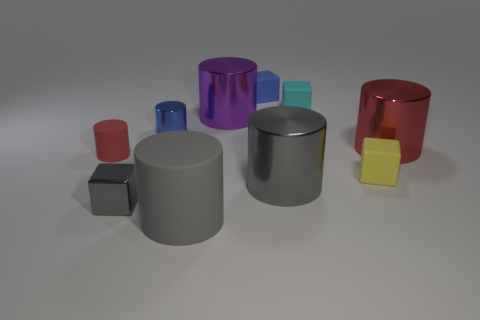Is the number of big gray objects behind the tiny blue metallic cylinder the same as the number of gray matte cylinders behind the yellow block?
Offer a terse response. Yes. There is a tiny metallic thing behind the red cylinder on the left side of the large purple metal thing; are there any metal cubes that are to the left of it?
Provide a succinct answer. Yes. Do the gray block and the blue metallic cylinder have the same size?
Your response must be concise. Yes. There is a cylinder left of the tiny shiny thing in front of the red cylinder left of the big red metal cylinder; what is its color?
Your answer should be compact. Red. How many big rubber objects have the same color as the shiny cube?
Offer a very short reply. 1. What number of tiny objects are either red metallic cylinders or brown matte spheres?
Offer a very short reply. 0. Is there a small blue rubber thing that has the same shape as the yellow matte thing?
Ensure brevity in your answer.  Yes. Do the tiny red matte thing and the tiny gray shiny object have the same shape?
Your answer should be compact. No. What is the color of the tiny metal object that is in front of the matte cylinder left of the large matte thing?
Give a very brief answer. Gray. What color is the metal block that is the same size as the yellow rubber object?
Offer a terse response. Gray. 